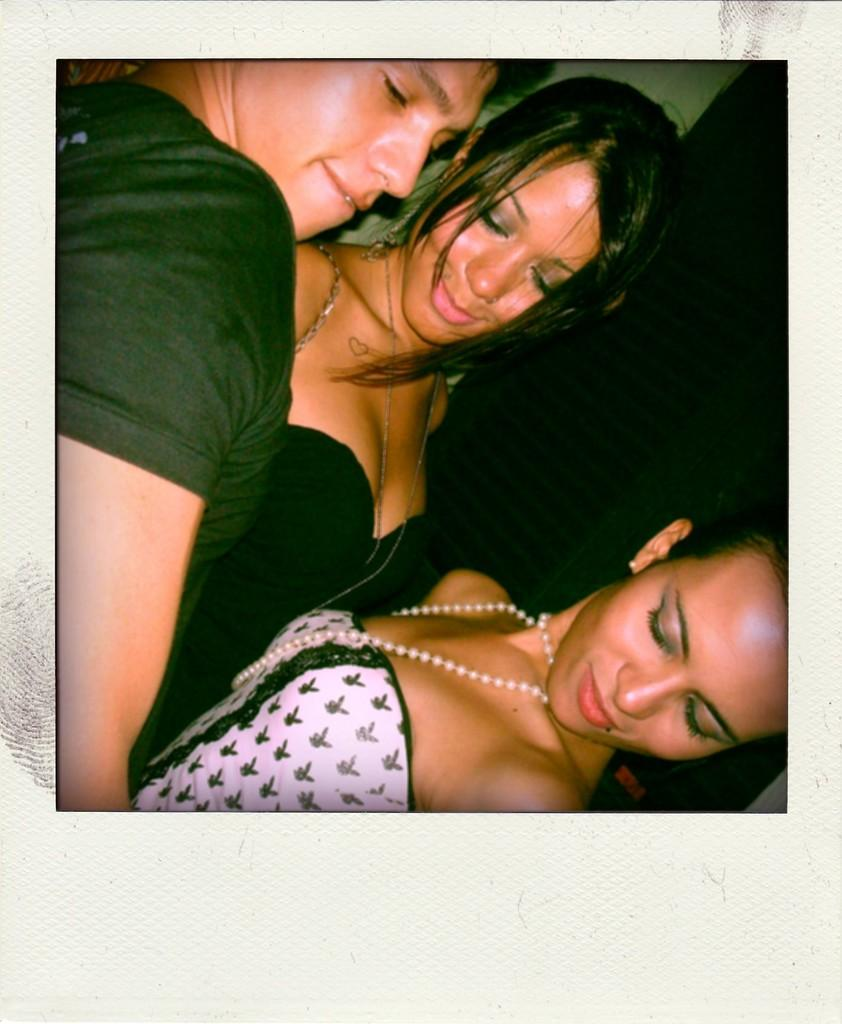What is the main subject of the image? The main subject of the image is a group of people. What can be observed about the appearance of the people in the group? The people in the group have black hair. What type of bun is being served at the event in the image? There is no event or bun present in the image; it only features a group of people with black hair. What kind of band is performing in the background of the image? There is no band or performance present in the image; it only features a group of people with black hair. 